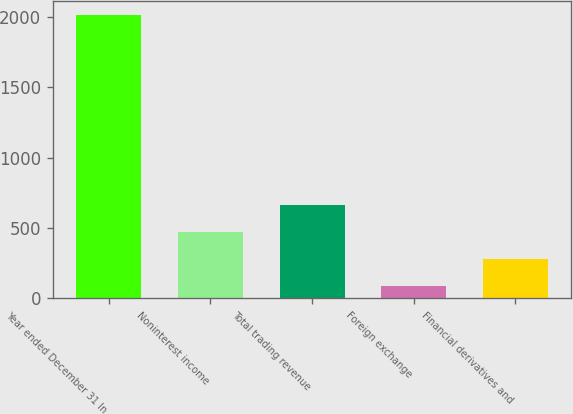<chart> <loc_0><loc_0><loc_500><loc_500><bar_chart><fcel>Year ended December 31 In<fcel>Noninterest income<fcel>Total trading revenue<fcel>Foreign exchange<fcel>Financial derivatives and<nl><fcel>2011<fcel>472.6<fcel>664.9<fcel>88<fcel>280.3<nl></chart> 